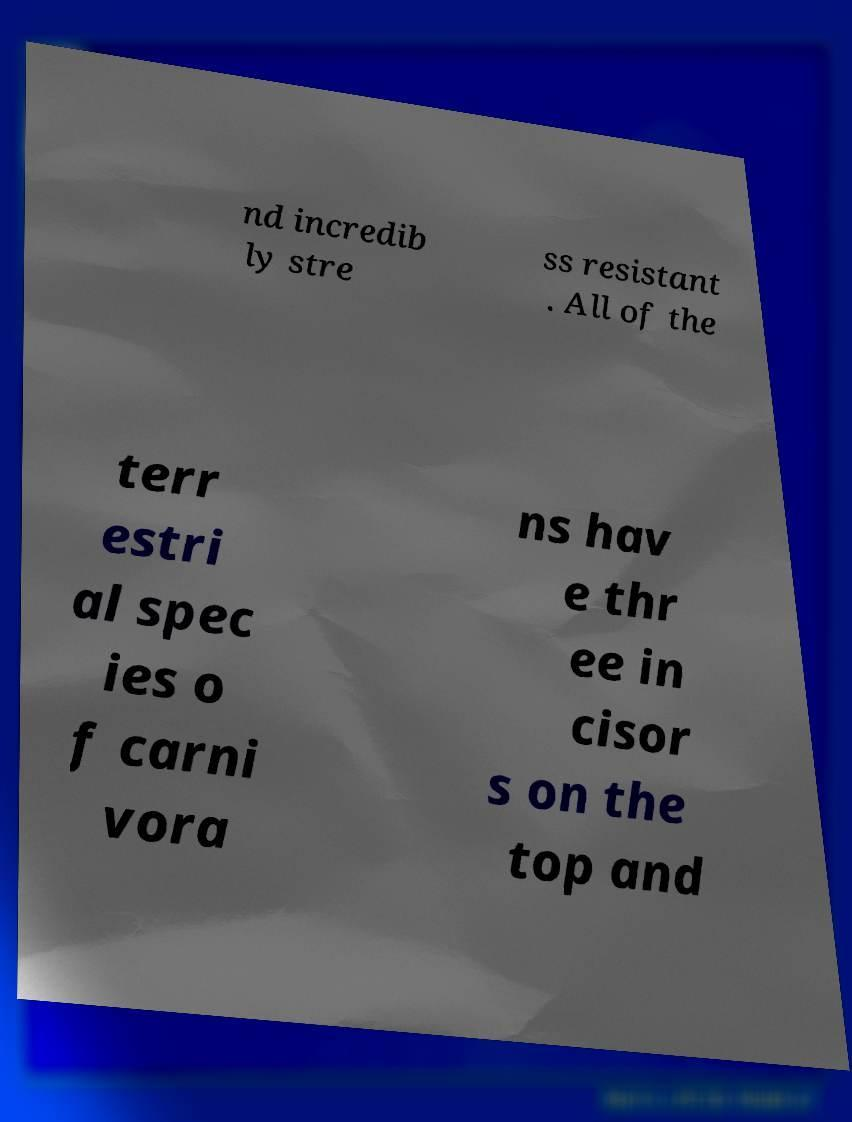Please read and relay the text visible in this image. What does it say? nd incredib ly stre ss resistant . All of the terr estri al spec ies o f carni vora ns hav e thr ee in cisor s on the top and 